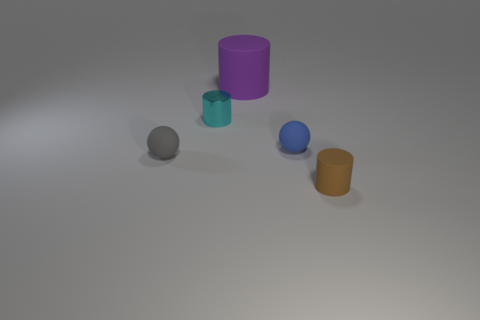Do the small rubber thing that is behind the small gray rubber thing and the big purple rubber object have the same shape?
Ensure brevity in your answer.  No. What number of gray spheres have the same material as the small brown cylinder?
Keep it short and to the point. 1. What number of things are either small shiny cylinders that are behind the tiny blue thing or tiny rubber blocks?
Offer a very short reply. 1. The blue ball is what size?
Make the answer very short. Small. What material is the cylinder that is to the left of the matte cylinder that is behind the tiny brown cylinder made of?
Your answer should be compact. Metal. Is the size of the matte sphere that is on the right side of the purple rubber cylinder the same as the gray ball?
Provide a short and direct response. Yes. Is there a large ball of the same color as the shiny cylinder?
Make the answer very short. No. What number of objects are either matte cylinders in front of the cyan object or matte cylinders that are behind the shiny cylinder?
Offer a very short reply. 2. Is the number of big matte cylinders that are behind the small cyan cylinder less than the number of tiny rubber spheres on the left side of the brown matte object?
Keep it short and to the point. Yes. Are the purple cylinder and the tiny gray ball made of the same material?
Offer a terse response. Yes. 